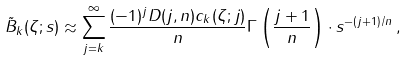Convert formula to latex. <formula><loc_0><loc_0><loc_500><loc_500>\tilde { B } _ { k } ( \zeta ; s ) \approx \sum _ { j = k } ^ { \infty } \frac { ( - 1 ) ^ { j } D ( j , n ) c _ { k } ( \zeta ; j ) } { n } \Gamma \left ( \frac { j + 1 } { n } \right ) \cdot s ^ { - ( j + 1 ) / n } \, ,</formula> 